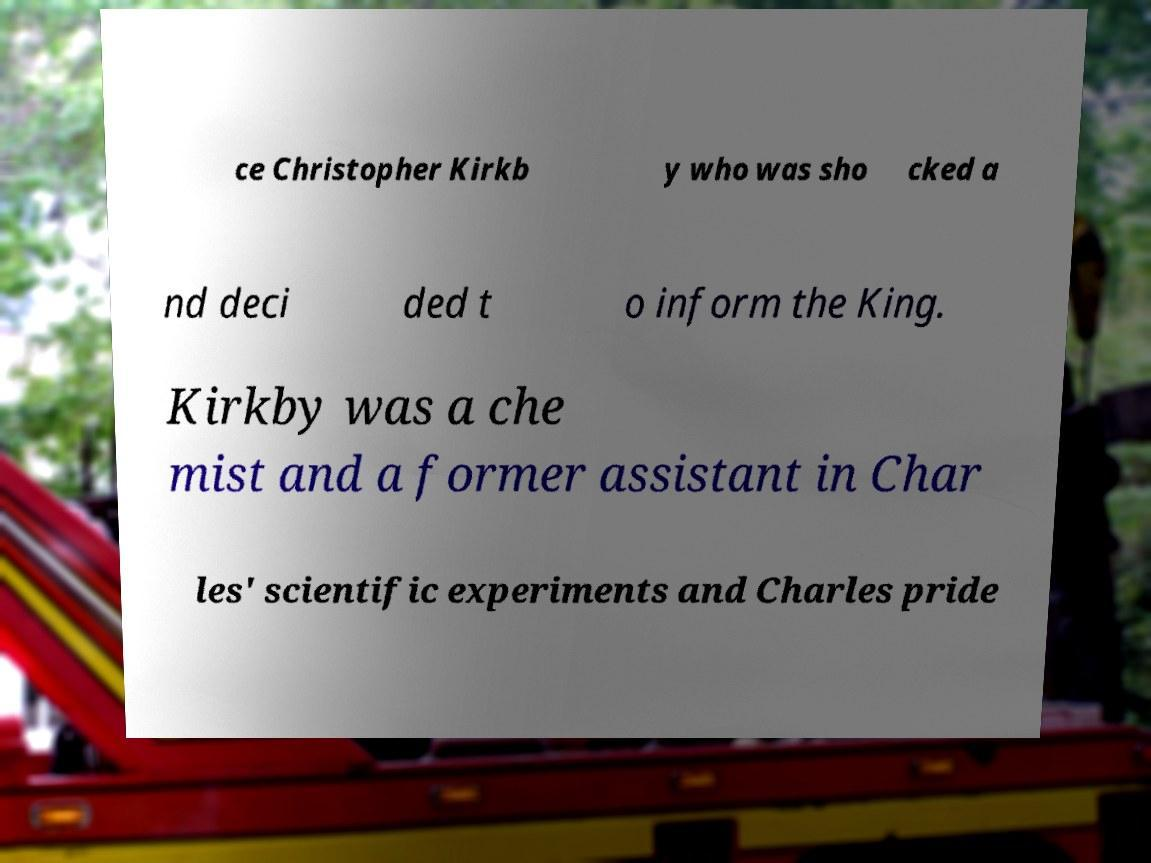Please identify and transcribe the text found in this image. ce Christopher Kirkb y who was sho cked a nd deci ded t o inform the King. Kirkby was a che mist and a former assistant in Char les' scientific experiments and Charles pride 